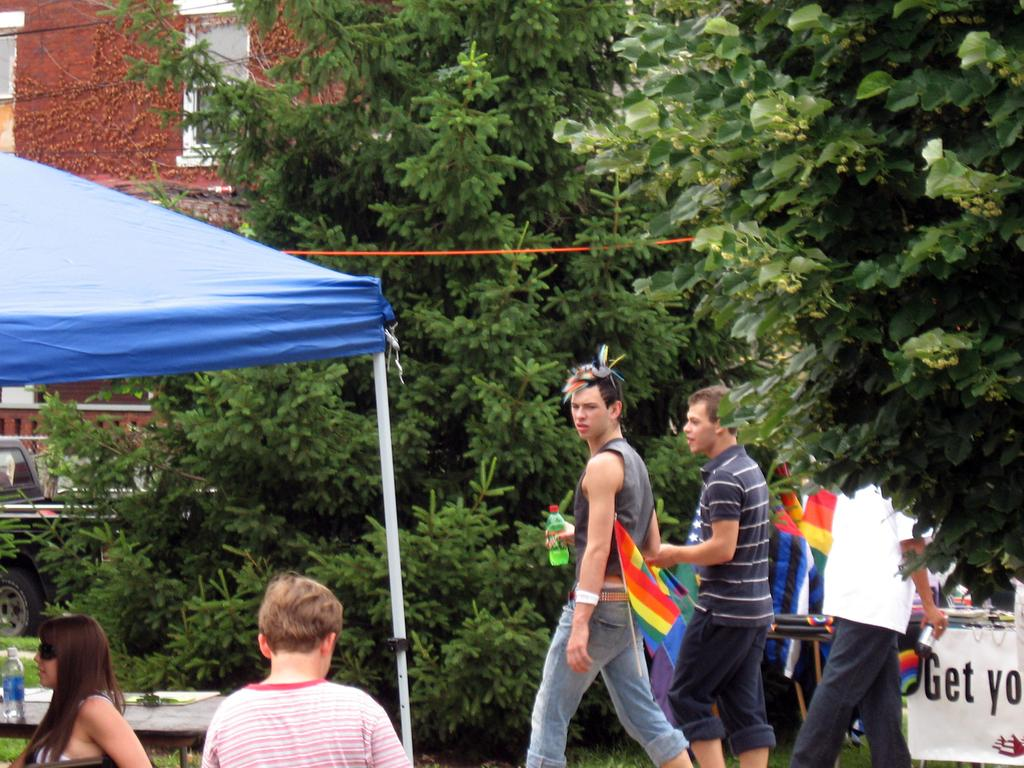What is on the table in the image? There is a bottle and other objects on the table in the image. What can be seen in the image besides the table? There is a tent, a banner, flags, trees, and a building in the image. What is the background of the image? The background of the image includes trees and a building. What type of scent can be smelled from the credit card in the image? There is no credit card present in the image, and therefore no scent can be associated with it. 